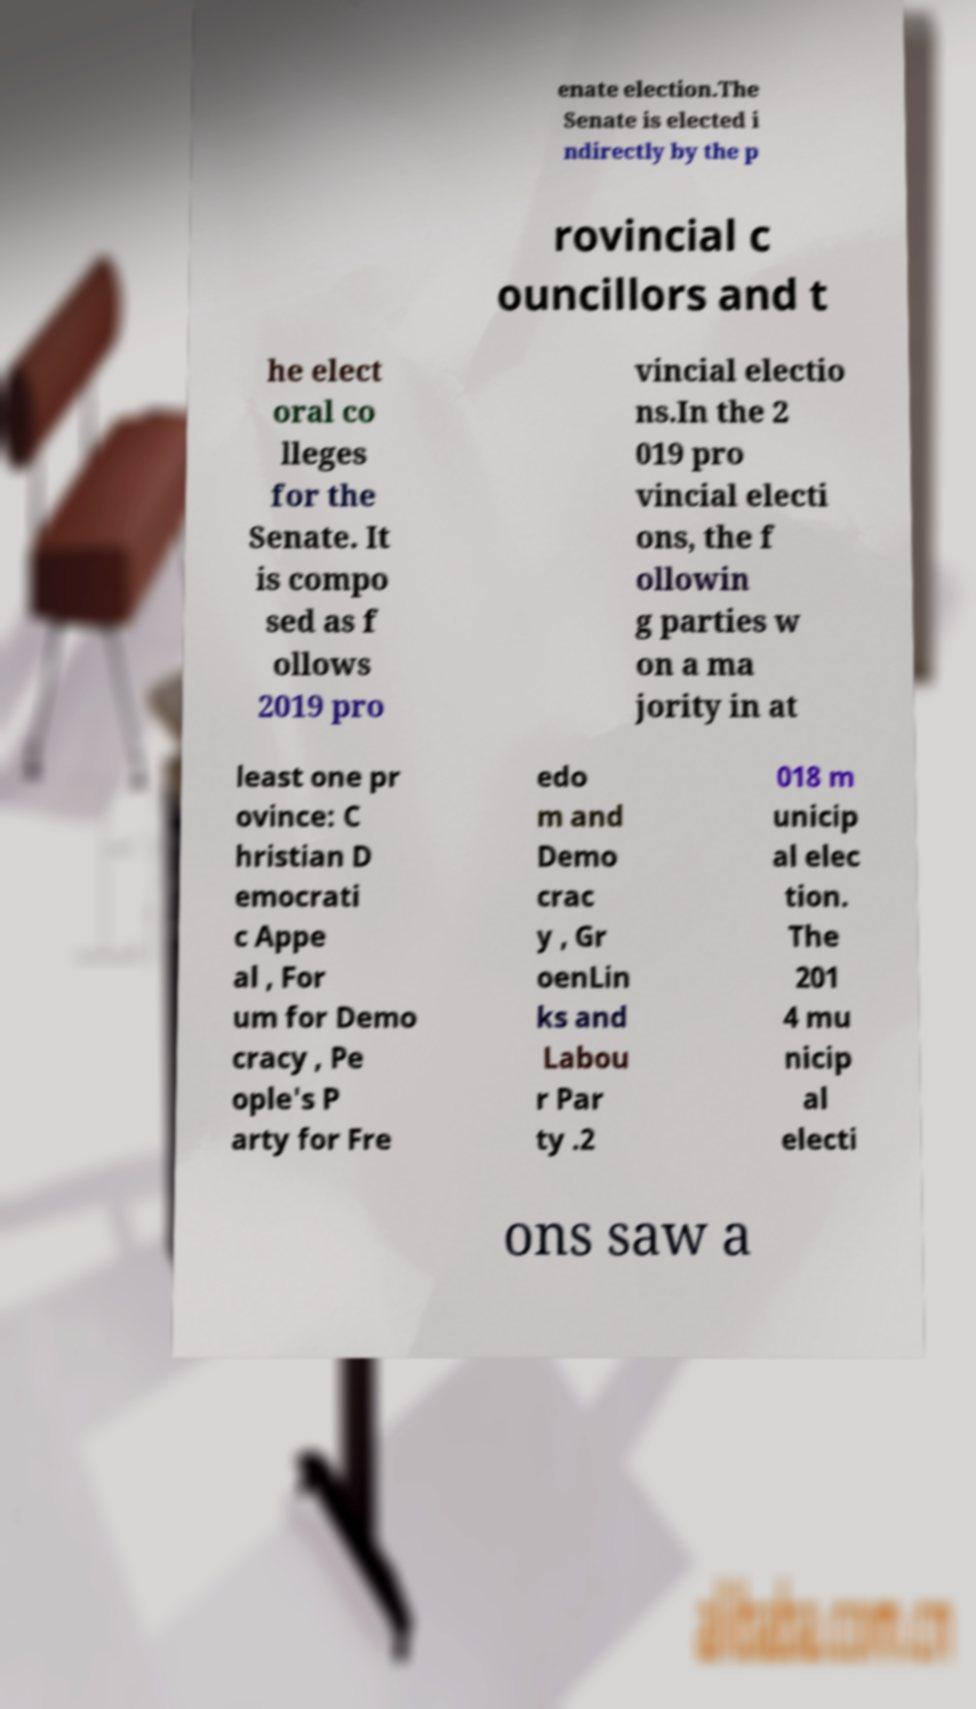What messages or text are displayed in this image? I need them in a readable, typed format. enate election.The Senate is elected i ndirectly by the p rovincial c ouncillors and t he elect oral co lleges for the Senate. It is compo sed as f ollows 2019 pro vincial electio ns.In the 2 019 pro vincial electi ons, the f ollowin g parties w on a ma jority in at least one pr ovince: C hristian D emocrati c Appe al , For um for Demo cracy , Pe ople's P arty for Fre edo m and Demo crac y , Gr oenLin ks and Labou r Par ty .2 018 m unicip al elec tion. The 201 4 mu nicip al electi ons saw a 